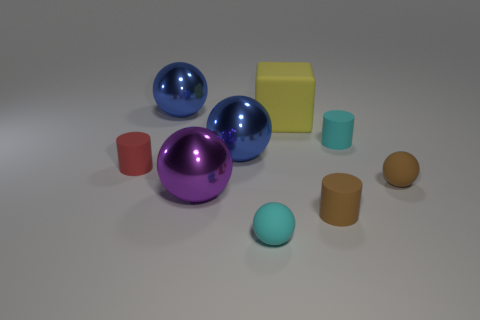Subtract 1 spheres. How many spheres are left? 4 Subtract all cyan spheres. How many spheres are left? 4 Subtract all tiny cyan matte spheres. How many spheres are left? 4 Subtract all gray balls. Subtract all brown blocks. How many balls are left? 5 Add 1 big metal objects. How many objects exist? 10 Subtract all blocks. How many objects are left? 8 Subtract 1 brown cylinders. How many objects are left? 8 Subtract all tiny red things. Subtract all red rubber things. How many objects are left? 7 Add 4 big purple objects. How many big purple objects are left? 5 Add 6 big yellow metal cylinders. How many big yellow metal cylinders exist? 6 